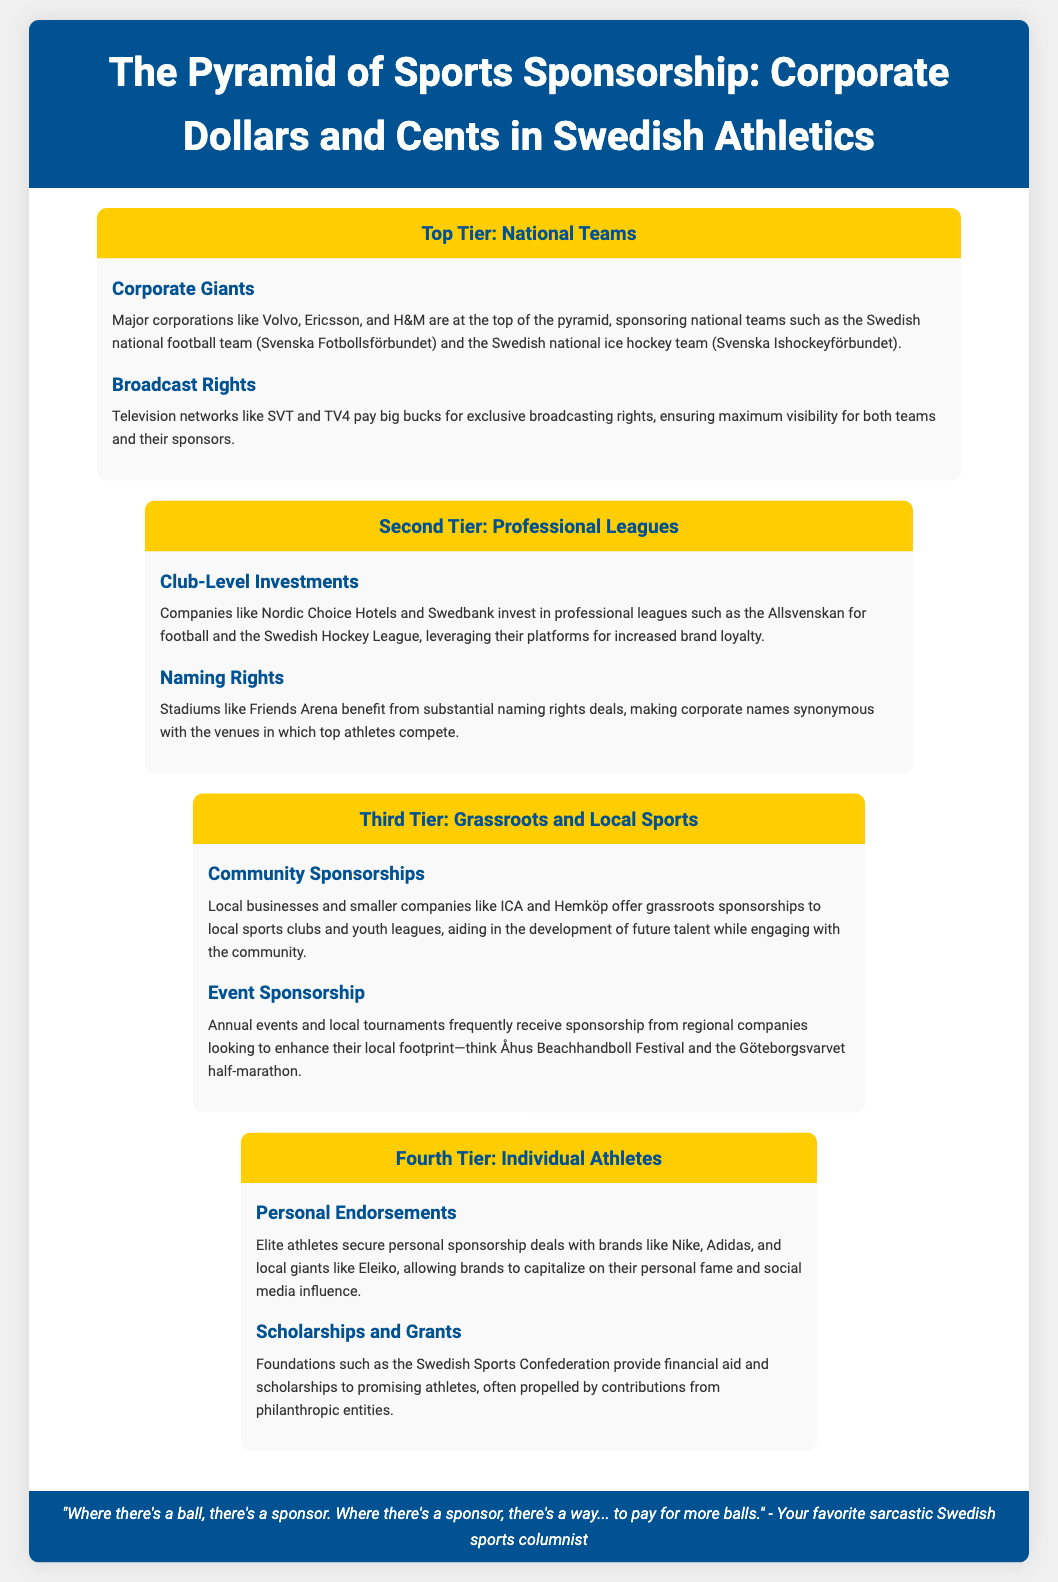What corporations sponsor national teams? The document lists major corporations like Volvo, Ericsson, and H&M as sponsors for national teams.
Answer: Volvo, Ericsson, H&M Which two television networks pay for broadcasting rights? The networks mentioned for paying big bucks for broadcasting rights are SVT and TV4.
Answer: SVT, TV4 What is an example of a stadium benefiting from naming rights deals? Friends Arena is provided as an example of a stadium with substantial naming rights deals.
Answer: Friends Arena Who provides scholarships to promising athletes? The Swedish Sports Confederation is mentioned as providing financial aid and scholarships to athletes.
Answer: Swedish Sports Confederation Which companies typically engage in grassroots sponsorships? Local businesses and smaller companies like ICA and Hemköp are noted for offering grassroots sponsorships.
Answer: ICA, Hemköp What type of sponsorship do elite athletes secure with brands? The document states that elite athletes secure personal endorsements with brands.
Answer: Personal endorsements What is the primary aim of regional companies sponsoring local events? The aim of regional companies sponsoring local events is to enhance their local footprint.
Answer: Enhance local footprint What is the tier level for individual athletes in the sponsorship pyramid? Individual athletes are placed in the fourth tier of the sponsorship pyramid.
Answer: Fourth Tier 